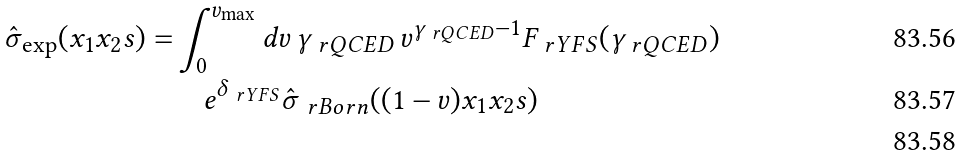<formula> <loc_0><loc_0><loc_500><loc_500>\hat { \sigma } _ { \exp } ( x _ { 1 } x _ { 2 } s ) = & \int ^ { v _ { \max } } _ { 0 } d v \, \gamma _ { \ r Q C E D } \, v ^ { \gamma _ { \ r Q C E D } - 1 } F _ { \ r Y F S } ( \gamma _ { \ r Q C E D } ) \\ & \quad e ^ { \delta _ { \ r Y F S } } \hat { \sigma } _ { \ r B o r n } ( ( 1 - v ) x _ { 1 } x _ { 2 } s ) \\</formula> 